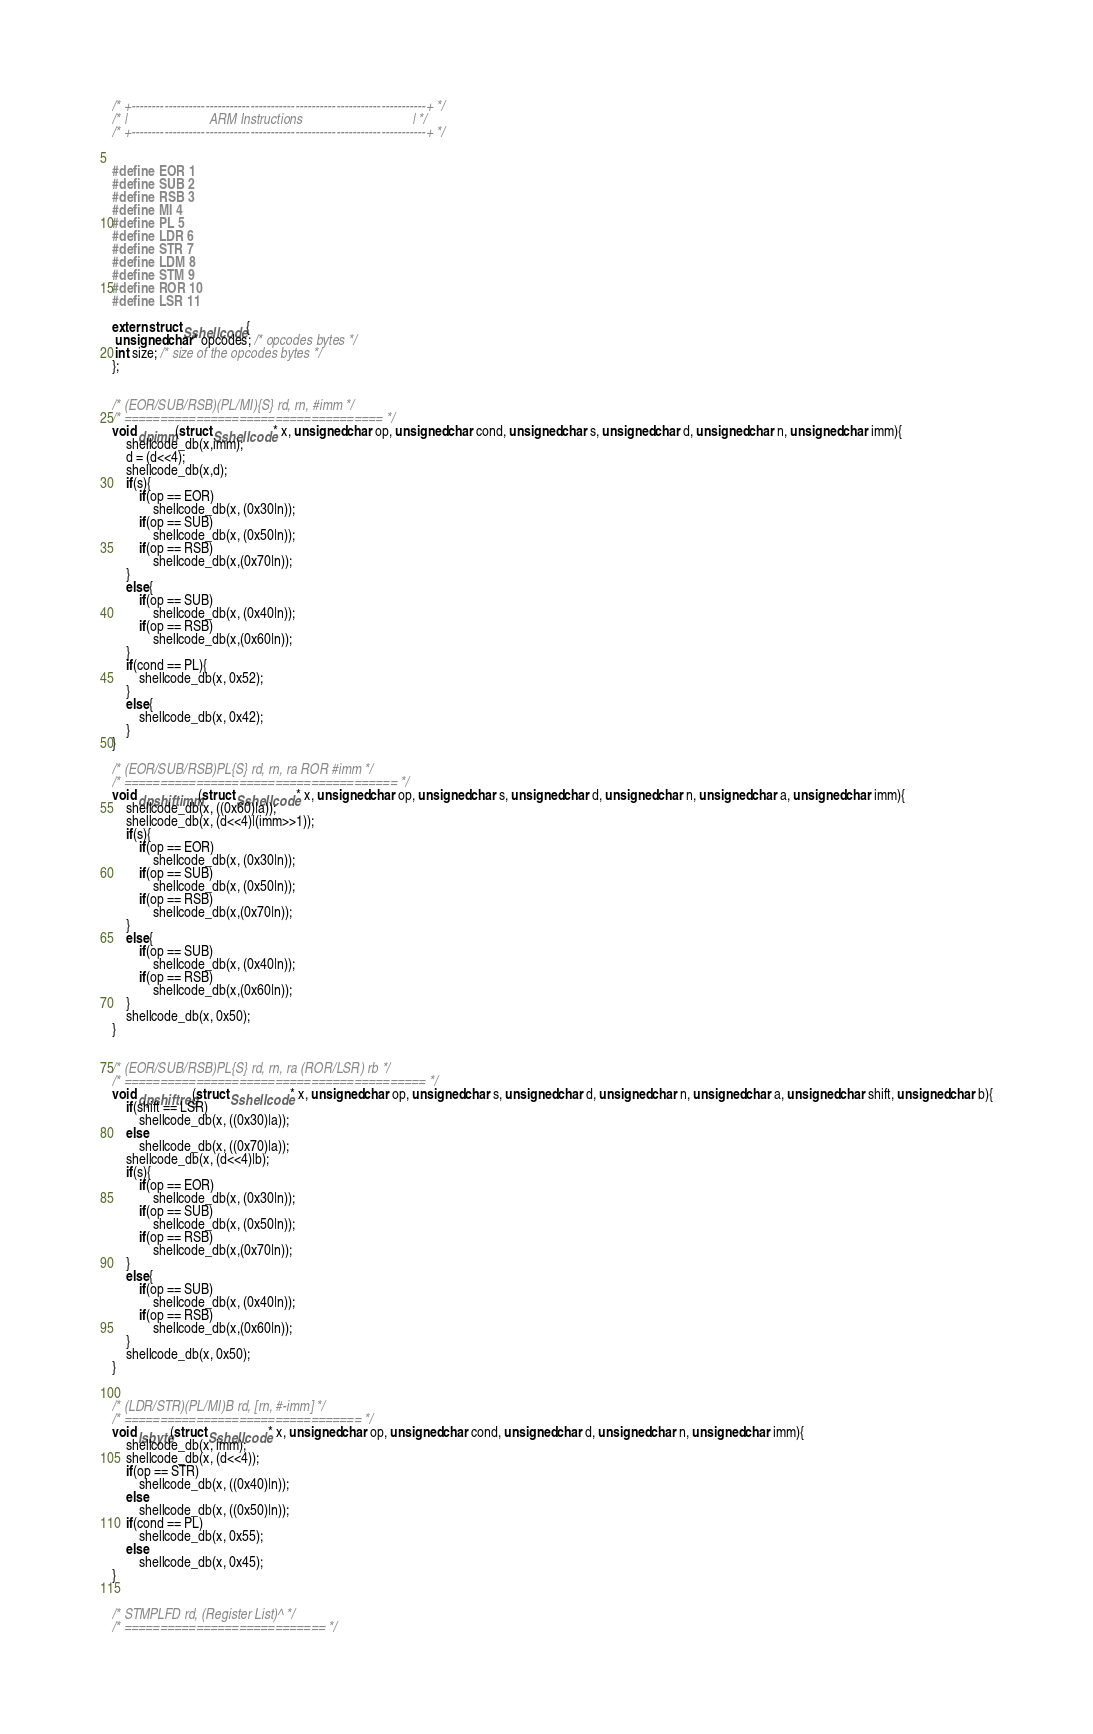Convert code to text. <code><loc_0><loc_0><loc_500><loc_500><_C_>

/* +------------------------------------------------------------------------+ */
/* |                        ARM Instructions                                | */
/* +------------------------------------------------------------------------+ */


#define EOR 1
#define SUB 2
#define RSB 3
#define MI 4
#define PL 5 
#define LDR 6
#define STR 7
#define LDM 8
#define STM 9
#define ROR 10
#define LSR 11

extern struct Sshellcode {
 unsigned char* opcodes; /* opcodes bytes */
 int size; /* size of the opcodes bytes */
};


/* (EOR/SUB/RSB)(PL/MI){S} rd, rn, #imm */
/* ==================================== */
void dpimm(struct Sshellcode* x, unsigned char op, unsigned char cond, unsigned char s, unsigned char d, unsigned char n, unsigned char imm){
	shellcode_db(x,imm);
	d = (d<<4);
	shellcode_db(x,d);
	if(s){
		if(op == EOR)
			shellcode_db(x, (0x30|n));
		if(op == SUB)
			shellcode_db(x, (0x50|n));
		if(op == RSB)
			shellcode_db(x,(0x70|n));		
	}				
	else{
		if(op == SUB)
			shellcode_db(x, (0x40|n));
		if(op == RSB)
			shellcode_db(x,(0x60|n));
	}
	if(cond == PL){
		shellcode_db(x, 0x52);
	}
	else{
		shellcode_db(x, 0x42);
	}
}

/* (EOR/SUB/RSB)PL{S} rd, rn, ra ROR #imm */
/* ====================================== */
void dpshiftimm(struct Sshellcode* x, unsigned char op, unsigned char s, unsigned char d, unsigned char n, unsigned char a, unsigned char imm){
	shellcode_db(x, ((0x60)|a));
	shellcode_db(x, (d<<4)|(imm>>1));
	if(s){
		if(op == EOR)
			shellcode_db(x, (0x30|n));
		if(op == SUB)
			shellcode_db(x, (0x50|n));
		if(op == RSB)
			shellcode_db(x,(0x70|n));		
	}				
	else{
		if(op == SUB)
			shellcode_db(x, (0x40|n));
		if(op == RSB)
			shellcode_db(x,(0x60|n));
	}
	shellcode_db(x, 0x50);	
}


/* (EOR/SUB/RSB)PL{S} rd, rn, ra (ROR/LSR) rb */
/* ========================================== */
void dpshiftreg(struct Sshellcode* x, unsigned char op, unsigned char s, unsigned char d, unsigned char n, unsigned char a, unsigned char shift, unsigned char b){
	if(shift == LSR)
		shellcode_db(x, ((0x30)|a));
	else	
		shellcode_db(x, ((0x70)|a));
	shellcode_db(x, (d<<4)|b);
	if(s){
		if(op == EOR)
			shellcode_db(x, (0x30|n));
		if(op == SUB)
			shellcode_db(x, (0x50|n));
		if(op == RSB)
			shellcode_db(x,(0x70|n));		
	}				
	else{
		if(op == SUB)
			shellcode_db(x, (0x40|n));
		if(op == RSB)
			shellcode_db(x,(0x60|n));
	}
	shellcode_db(x, 0x50);
}


/* (LDR/STR)(PL/MI)B rd, [rn, #-imm] */
/* ================================= */
void lsbyte(struct Sshellcode* x, unsigned char op, unsigned char cond, unsigned char d, unsigned char n, unsigned char imm){
	shellcode_db(x, imm);
	shellcode_db(x, (d<<4));
	if(op == STR)
		shellcode_db(x, ((0x40)|n));
	else 
		shellcode_db(x, ((0x50)|n));
	if(cond == PL)
		shellcode_db(x, 0x55);
	else
		shellcode_db(x, 0x45);		
}


/* STMPLFD rd, (Register List)^ */
/* ============================ */</code> 